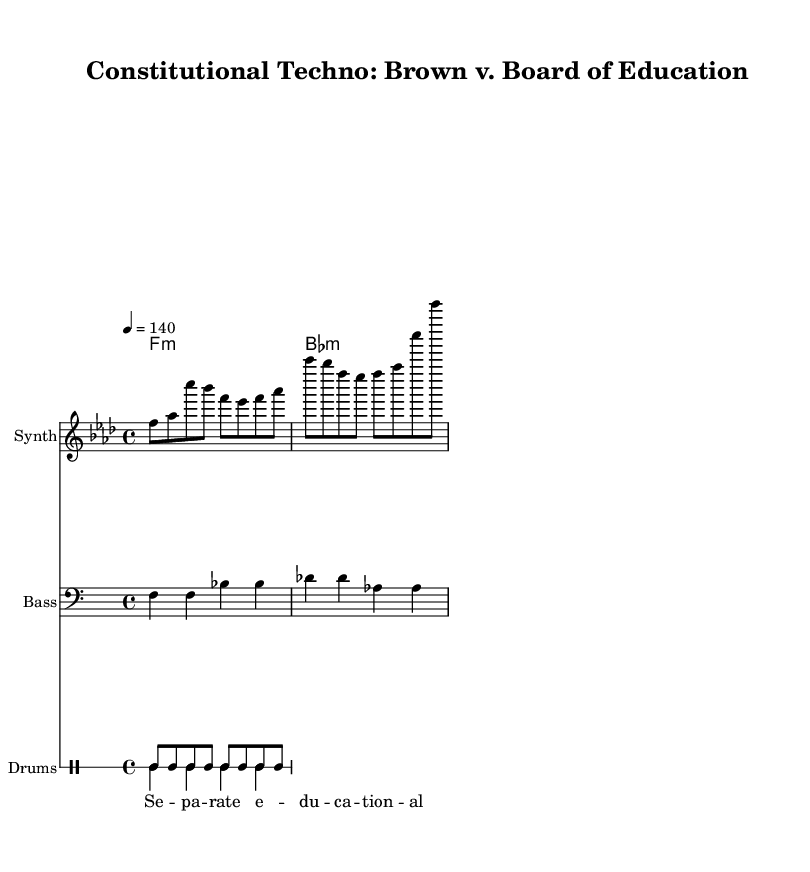What is the key signature of this music? The key signature is indicated at the beginning of the staff with flats. In this piece, there are six flats shown, which corresponds to the key of F minor.
Answer: F minor What is the time signature of this piece? The time signature is indicated at the beginning of the score, shown as a fraction. It displays "4/4", which means there are four beats in each measure and the quarter note receives one beat.
Answer: 4/4 What is the tempo marking of the music? The tempo marking is provided after the time signature and states "4 = 140". This indicates that the quarter note is set to a speed of 140 beats per minute.
Answer: 140 How many measures are indicated in the melody? To determine the number of measures, we can count the measure bars indicated in the melody line. The melody section comprises three measures as defined by the line breaks.
Answer: 3 What instruments are used in this arrangement? The instruments are specified at the beginning of each staff. The score includes a "Synth" for the melody, "Bass" for the bass line, and "Drums" for the percussion patterns.
Answer: Synth, Bass, Drums What style of music does this piece represent? The music style can be inferred from the title of the score and the use of energetic beats and synthesizers, which are characteristic of techno. The focus on high energy and rhythmic elements aligns with dance music genres.
Answer: Techno 